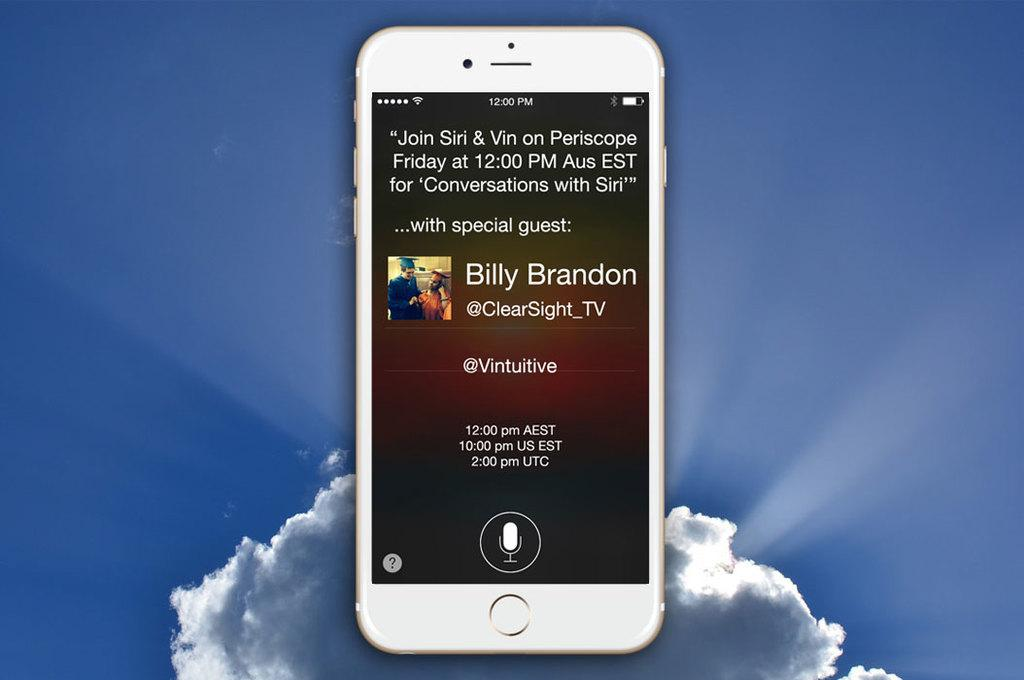What electronic device is visible in the image? There is a mobile phone in the image. Can you describe the condition of the mobile phone? There is some matter on the mobile phone. What is the good-bye message on the mobile phone in the image? There is no good-bye message visible on the mobile phone in the image. 